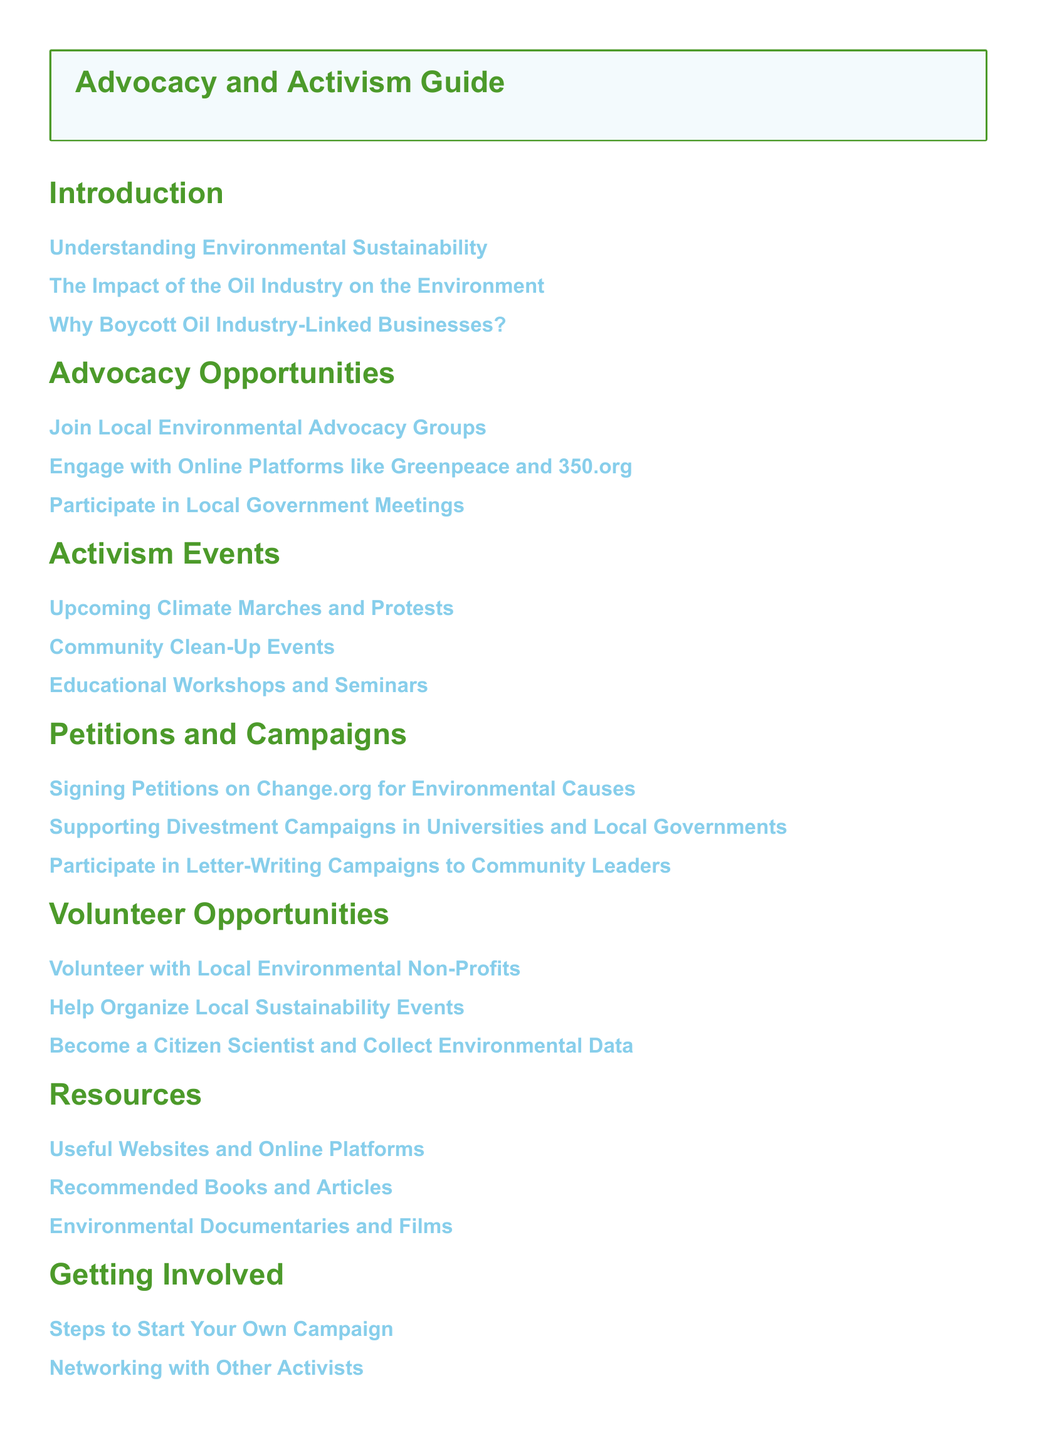What is the title of the guide? The title is mentioned in the table of contents and is a part of the document header.
Answer: Advocacy and Activism Guide How many sections are in the document? By counting the main sections in the table of contents, we find there are 7 sections.
Answer: 7 What type of organizations can you join for advocacy opportunities? The specific type of groups mentioned in the advocacy opportunities section.
Answer: Local Environmental Advocacy Groups Which online platforms are suggested for engagement? This information is indicated in the advocacy opportunities section of the document.
Answer: Greenpeace and 350.org What is one type of event listed under Activism Events? The types of events listed are specified in the activism events section.
Answer: Climate Marches Where can you find petitions for environmental causes? This can be found in the petitions and campaigns section of the document.
Answer: Change.org What is one way to get involved mentioned in the document? This refers to the actionable steps provided in the getting involved section.
Answer: Start Your Own Campaign What color is associated with titles in the document? The visual representation of titles can be inferred from the document formatting section.
Answer: Leaf green How many volunteer opportunities are listed? The number of volunteer opportunities can be counted in the volunteer opportunities section.
Answer: 3 